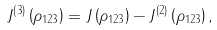Convert formula to latex. <formula><loc_0><loc_0><loc_500><loc_500>J ^ { \left ( 3 \right ) } \left ( \rho _ { 1 2 3 } \right ) = J \left ( \rho _ { 1 2 3 } \right ) - J ^ { \left ( 2 \right ) } \left ( \rho _ { 1 2 3 } \right ) ,</formula> 